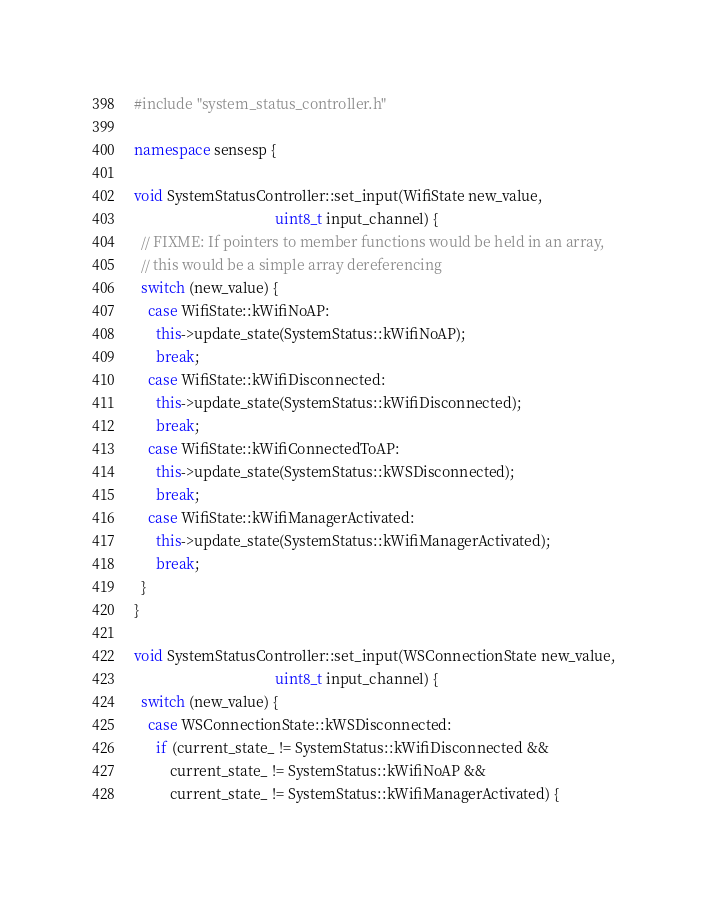<code> <loc_0><loc_0><loc_500><loc_500><_C++_>#include "system_status_controller.h"

namespace sensesp {

void SystemStatusController::set_input(WifiState new_value,
                                       uint8_t input_channel) {
  // FIXME: If pointers to member functions would be held in an array,
  // this would be a simple array dereferencing
  switch (new_value) {
    case WifiState::kWifiNoAP:
      this->update_state(SystemStatus::kWifiNoAP);
      break;
    case WifiState::kWifiDisconnected:
      this->update_state(SystemStatus::kWifiDisconnected);
      break;
    case WifiState::kWifiConnectedToAP:
      this->update_state(SystemStatus::kWSDisconnected);
      break;
    case WifiState::kWifiManagerActivated:
      this->update_state(SystemStatus::kWifiManagerActivated);
      break;
  }
}

void SystemStatusController::set_input(WSConnectionState new_value,
                                       uint8_t input_channel) {
  switch (new_value) {
    case WSConnectionState::kWSDisconnected:
      if (current_state_ != SystemStatus::kWifiDisconnected &&
          current_state_ != SystemStatus::kWifiNoAP &&
          current_state_ != SystemStatus::kWifiManagerActivated) {</code> 